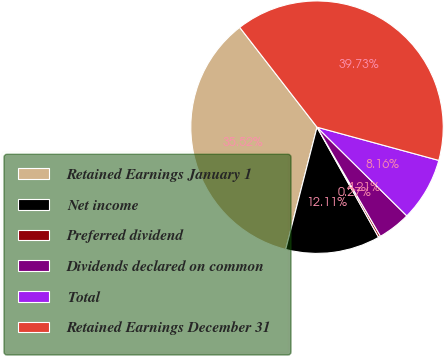Convert chart to OTSL. <chart><loc_0><loc_0><loc_500><loc_500><pie_chart><fcel>Retained Earnings January 1<fcel>Net income<fcel>Preferred dividend<fcel>Dividends declared on common<fcel>Total<fcel>Retained Earnings December 31<nl><fcel>35.52%<fcel>12.11%<fcel>0.27%<fcel>4.21%<fcel>8.16%<fcel>39.73%<nl></chart> 